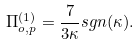<formula> <loc_0><loc_0><loc_500><loc_500>\Pi ^ { ( 1 ) } _ { o , p } = \frac { 7 } { 3 \kappa } s g n ( \kappa ) .</formula> 